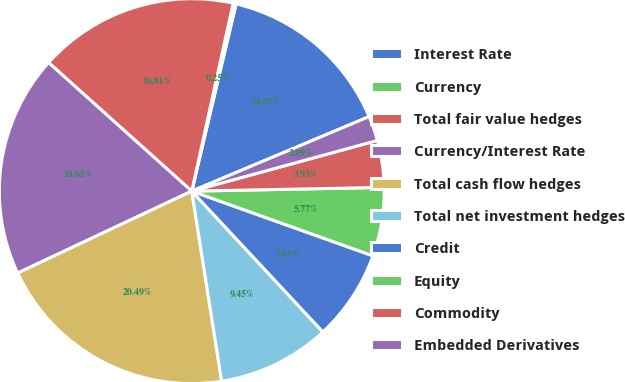Convert chart. <chart><loc_0><loc_0><loc_500><loc_500><pie_chart><fcel>Interest Rate<fcel>Currency<fcel>Total fair value hedges<fcel>Currency/Interest Rate<fcel>Total cash flow hedges<fcel>Total net investment hedges<fcel>Credit<fcel>Equity<fcel>Commodity<fcel>Embedded Derivatives<nl><fcel>14.97%<fcel>0.25%<fcel>16.81%<fcel>18.65%<fcel>20.49%<fcel>9.45%<fcel>7.61%<fcel>5.77%<fcel>3.93%<fcel>2.09%<nl></chart> 